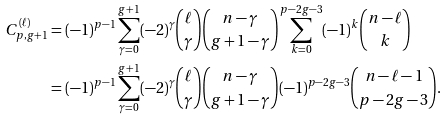Convert formula to latex. <formula><loc_0><loc_0><loc_500><loc_500>C _ { p , g + 1 } ^ { ( \ell ) } & = ( - 1 ) ^ { p - 1 } \sum _ { \gamma = 0 } ^ { g + 1 } ( - 2 ) ^ { \gamma } \binom { \ell } { \gamma } \binom { n - \gamma } { g + 1 - \gamma } \sum _ { k = 0 } ^ { p - 2 g - 3 } ( - 1 ) ^ { k } \binom { n - \ell } { k } \\ & = ( - 1 ) ^ { p - 1 } \sum _ { \gamma = 0 } ^ { g + 1 } ( - 2 ) ^ { \gamma } \binom { \ell } { \gamma } \binom { n - \gamma } { g + 1 - \gamma } ( - 1 ) ^ { p - 2 g - 3 } \binom { n - \ell - 1 } { p - 2 g - 3 } .</formula> 